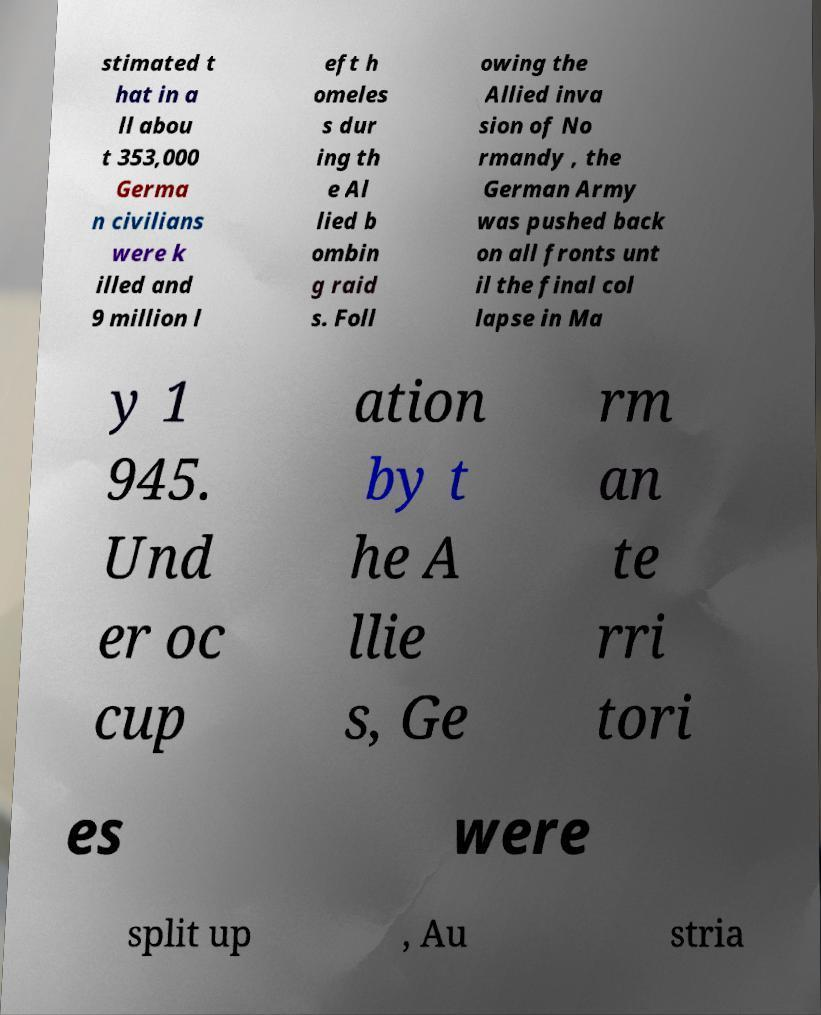Can you read and provide the text displayed in the image?This photo seems to have some interesting text. Can you extract and type it out for me? stimated t hat in a ll abou t 353,000 Germa n civilians were k illed and 9 million l eft h omeles s dur ing th e Al lied b ombin g raid s. Foll owing the Allied inva sion of No rmandy , the German Army was pushed back on all fronts unt il the final col lapse in Ma y 1 945. Und er oc cup ation by t he A llie s, Ge rm an te rri tori es were split up , Au stria 